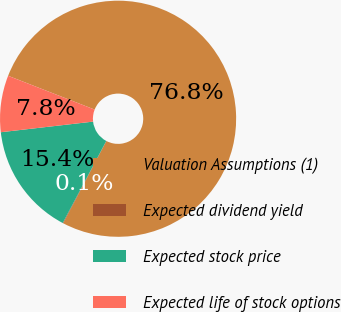Convert chart. <chart><loc_0><loc_0><loc_500><loc_500><pie_chart><fcel>Valuation Assumptions (1)<fcel>Expected dividend yield<fcel>Expected stock price<fcel>Expected life of stock options<nl><fcel>76.76%<fcel>0.08%<fcel>15.41%<fcel>7.75%<nl></chart> 